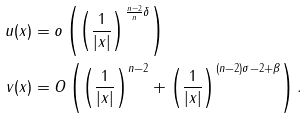<formula> <loc_0><loc_0><loc_500><loc_500>u ( x ) & = o \left ( \left ( \frac { 1 } { | x | } \right ) ^ { \frac { n - 2 } { n } \delta } \right ) \\ v ( x ) & = O \left ( \left ( \frac { 1 } { | x | } \right ) ^ { n - 2 } + \left ( \frac { 1 } { | x | } \right ) ^ { ( n - 2 ) \sigma - 2 + \beta } \right ) .</formula> 